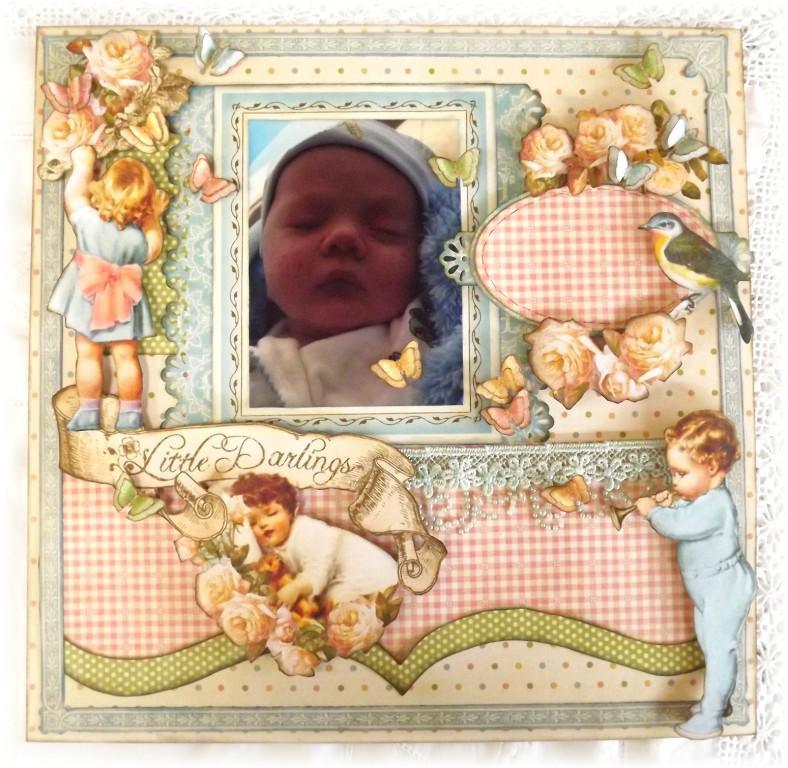What type of image is present in the image? The image contains an edited image. What is the main subject of the edited image? There is a picture of a baby in the image. How is the picture of the baby displayed? The baby's picture is arranged in a frame. What can be seen around the frame? There are decorations and animations around the frame. What type of pump can be seen in the image? There is no pump present in the image. What is the baby reading in the image? The baby is not reading anything in the image, as it is a picture of a baby and not an actual baby. 